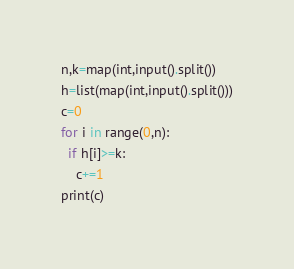<code> <loc_0><loc_0><loc_500><loc_500><_Python_>n,k=map(int,input().split())
h=list(map(int,input().split()))
c=0
for i in range(0,n):
  if h[i]>=k:
    c+=1
print(c)</code> 